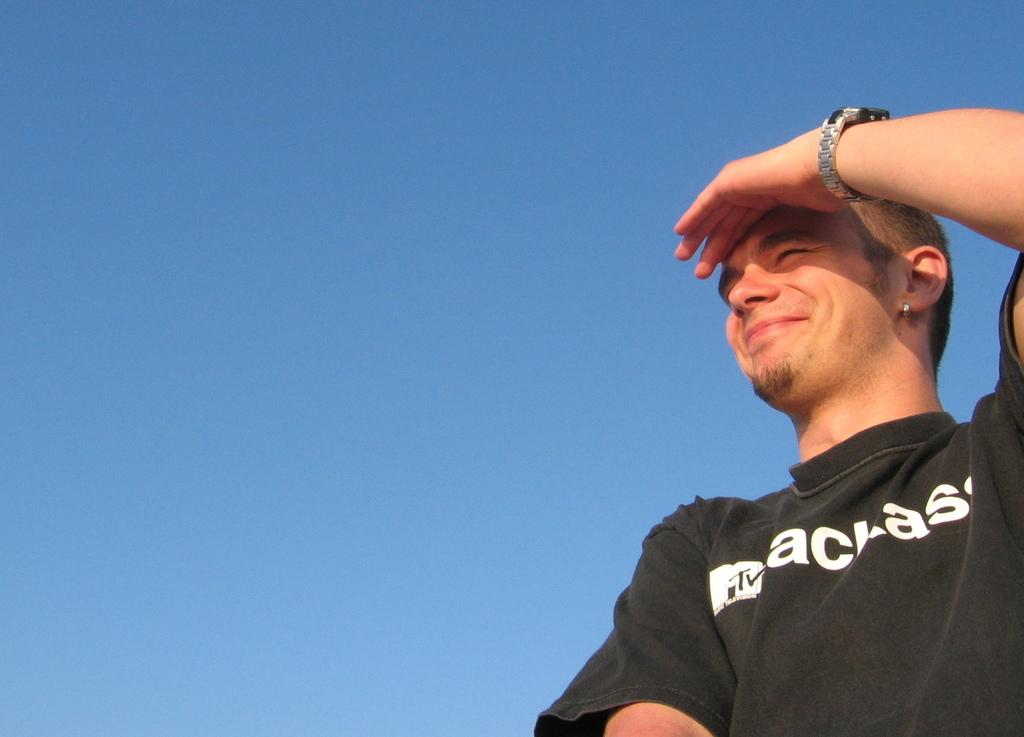What is the man in the image doing? The man is standing in the image. What is the man's facial expression? The man is smiling. What accessory is the man wearing? The man is wearing a watch. What can be seen in the background of the image? The sky is visible behind the man. What type of skirt is the man wearing in the image? The man is not wearing a skirt in the image; he is wearing a watch. 